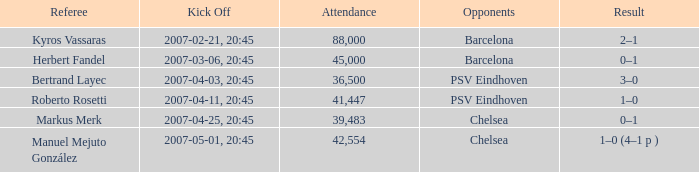WHAT OPPONENT HAD A KICKOFF OF 2007-03-06, 20:45? Barcelona. 